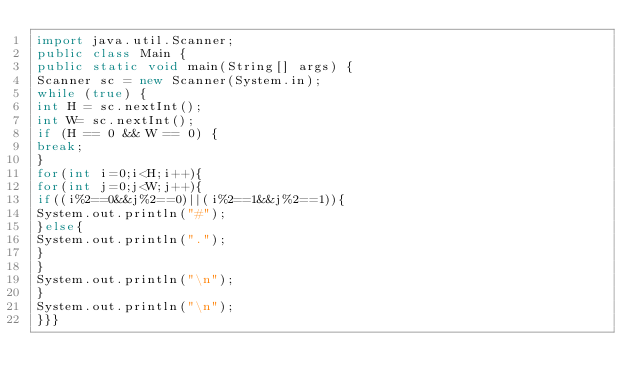<code> <loc_0><loc_0><loc_500><loc_500><_Java_>import java.util.Scanner;
public class Main {
public static void main(String[] args) {
Scanner sc = new Scanner(System.in);
while (true) {
int H = sc.nextInt();
int W= sc.nextInt();
if (H == 0 && W == 0) {
break;
}
for(int i=0;i<H;i++){
for(int j=0;j<W;j++){
if((i%2==0&&j%2==0)||(i%2==1&&j%2==1)){
System.out.println("#");
}else{
System.out.println(".");
}
}
System.out.println("\n");
}
System.out.println("\n");
}}}
</code> 